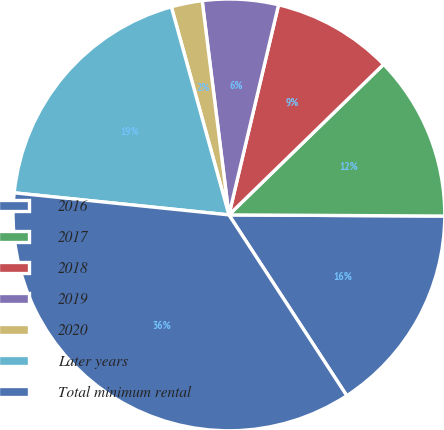<chart> <loc_0><loc_0><loc_500><loc_500><pie_chart><fcel>2016<fcel>2017<fcel>2018<fcel>2019<fcel>2020<fcel>Later years<fcel>Total minimum rental<nl><fcel>15.72%<fcel>12.37%<fcel>9.02%<fcel>5.67%<fcel>2.32%<fcel>19.07%<fcel>35.82%<nl></chart> 